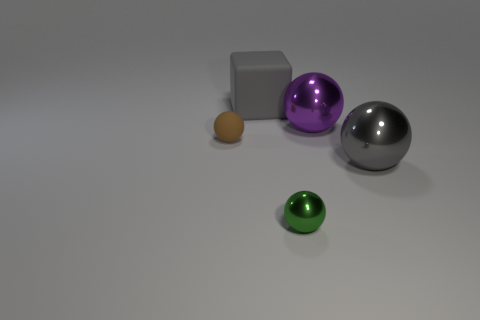Does the small matte thing have the same color as the big matte object?
Make the answer very short. No. Is there a yellow metallic object that has the same size as the brown rubber object?
Provide a succinct answer. No. What number of things are behind the tiny rubber object and left of the big purple ball?
Your response must be concise. 1. There is a large matte thing; how many large matte objects are to the left of it?
Your response must be concise. 0. Is there a small brown metal object of the same shape as the brown matte thing?
Provide a succinct answer. No. Is the shape of the small shiny object the same as the object that is left of the gray block?
Your answer should be very brief. Yes. What number of balls are either purple objects or metal objects?
Give a very brief answer. 3. The gray object that is on the left side of the green sphere has what shape?
Provide a short and direct response. Cube. How many tiny things are made of the same material as the gray sphere?
Your answer should be compact. 1. Are there fewer big rubber things that are on the right side of the large purple ball than big gray matte objects?
Your answer should be compact. Yes. 